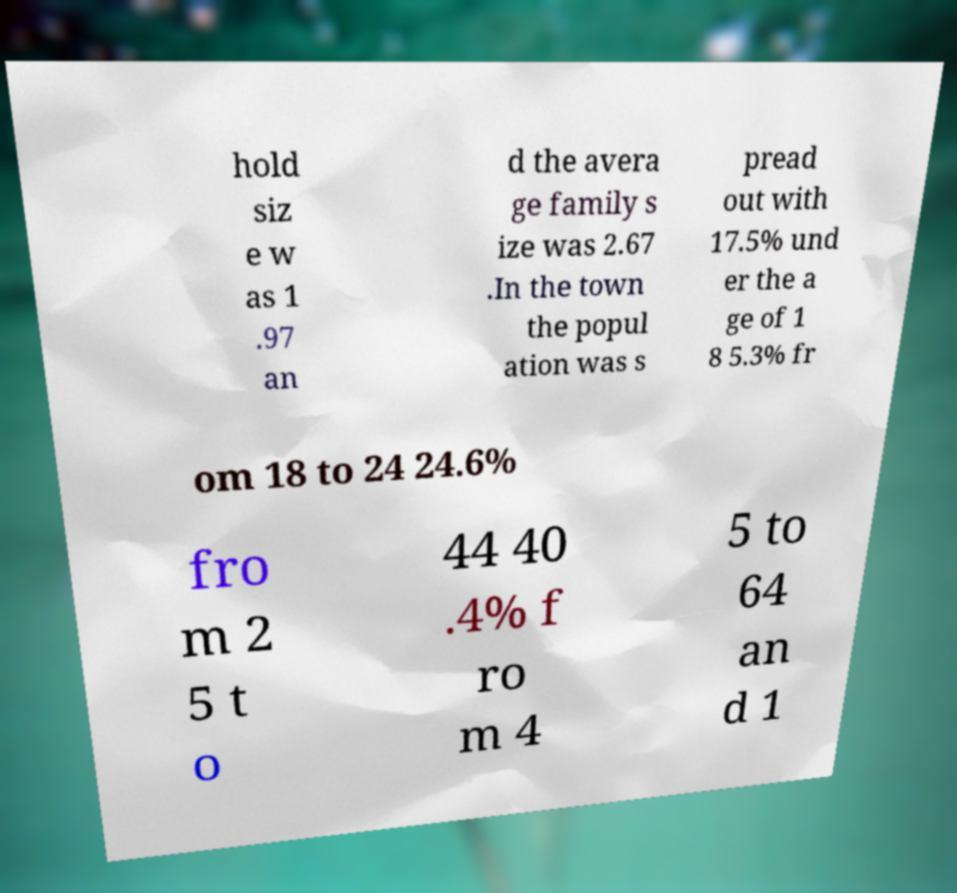Please identify and transcribe the text found in this image. hold siz e w as 1 .97 an d the avera ge family s ize was 2.67 .In the town the popul ation was s pread out with 17.5% und er the a ge of 1 8 5.3% fr om 18 to 24 24.6% fro m 2 5 t o 44 40 .4% f ro m 4 5 to 64 an d 1 